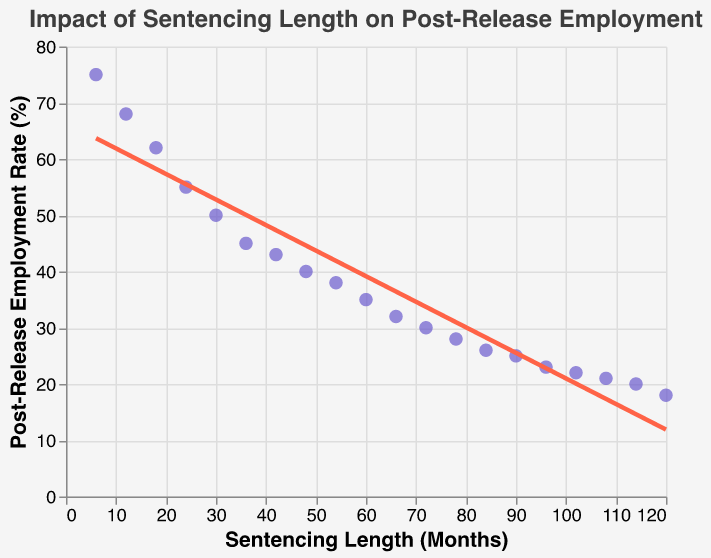What's the title of the plot? The title is visible at the top of the figure.
Answer: "Impact of Sentencing Length on Post-Release Employment" How many data points are plotted? We can count each individual point on the scatter plot or refer to the list of data points given.
Answer: 20 What is the employment rate for a sentencing length of 60 months? Locate the data point corresponding to 60 months on the x-axis and check its y-value.
Answer: 35% What trend does the trend line indicate about the relationship between sentencing length and employment rate? The downward slope of the trend line indicates a negative correlation; as sentencing length increases, the employment rate decreases.
Answer: Negative correlation Compare the employment rate between 24 months and 48 months of sentencing. Locate the points at 24 months and 48 months on the x-axis and compare their y-values.
Answer: 55% (24 months) vs. 40% (48 months) What is the approximate employment rate when sentencing length is 18 months? Find the data point at 18 months on the x-axis and check its y-value.
Answer: 62% Calculate the difference in employment rate between the shortest and longest sentencing lengths. The shortest sentencing length is 6 months with a rate of 75%, and the longest is 120 months with a rate of 18%. Subtract 18% from 75%.
Answer: 57% What is the general shape of the scatter plot? Observe the pattern of the plotted points; they form a downward pattern from left to right.
Answer: Downward trend Is there a point where the trend line significantly deviates from the data points? Observe the alignment of the data points with the trend line.
Answer: No significant deviations Which data point has the lowest post-release employment rate, and what is its sentencing length? Identify the data point with the lowest y-value (post-release employment rate).
Answer: 120 months with 18% employment rate 